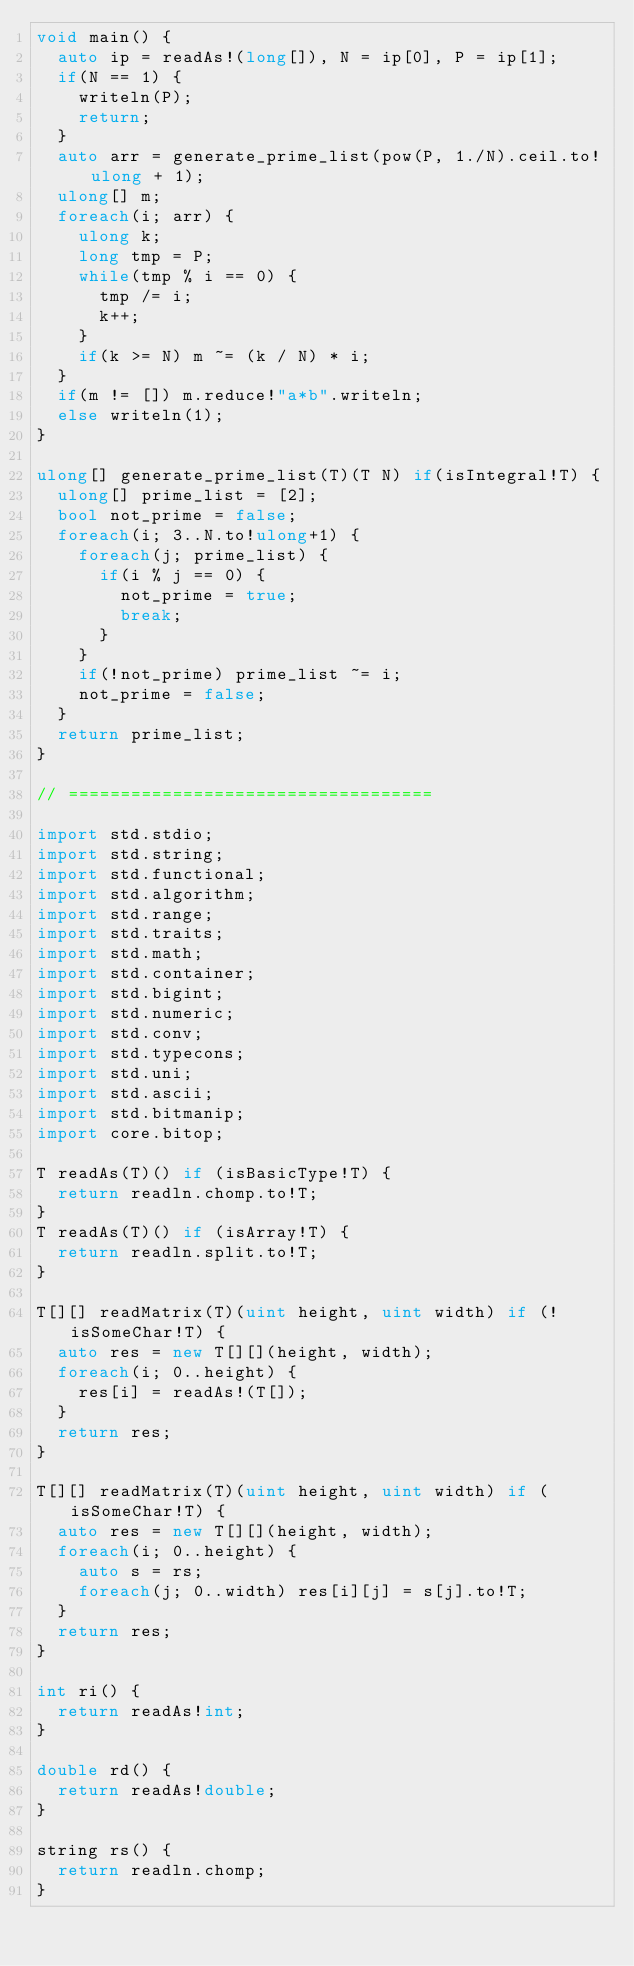<code> <loc_0><loc_0><loc_500><loc_500><_D_>void main() {
	auto ip = readAs!(long[]), N = ip[0], P = ip[1];
	if(N == 1) {
		writeln(P);
		return;
	}
	auto arr = generate_prime_list(pow(P, 1./N).ceil.to!ulong + 1);
	ulong[] m;
	foreach(i; arr) {
		ulong k;
		long tmp = P;
		while(tmp % i == 0) {
			tmp /= i;
			k++;
		}
		if(k >= N) m ~= (k / N) * i;
	}
	if(m != []) m.reduce!"a*b".writeln;
	else writeln(1);
}

ulong[] generate_prime_list(T)(T N) if(isIntegral!T) {
	ulong[] prime_list = [2];
	bool not_prime = false;
	foreach(i; 3..N.to!ulong+1) {
		foreach(j; prime_list) {
			if(i % j == 0) {
				not_prime = true;
				break;
			}
		}
		if(!not_prime) prime_list ~= i;
		not_prime = false;
	}
	return prime_list;
}

// ===================================

import std.stdio;
import std.string;
import std.functional;
import std.algorithm;
import std.range;
import std.traits;
import std.math;
import std.container;
import std.bigint;
import std.numeric;
import std.conv;
import std.typecons;
import std.uni;
import std.ascii;
import std.bitmanip;
import core.bitop;

T readAs(T)() if (isBasicType!T) {
	return readln.chomp.to!T;
}
T readAs(T)() if (isArray!T) {
	return readln.split.to!T;
}

T[][] readMatrix(T)(uint height, uint width) if (!isSomeChar!T) {
	auto res = new T[][](height, width);
	foreach(i; 0..height) {
		res[i] = readAs!(T[]);
	}
	return res;
}

T[][] readMatrix(T)(uint height, uint width) if (isSomeChar!T) {
	auto res = new T[][](height, width);
	foreach(i; 0..height) {
		auto s = rs;
		foreach(j; 0..width) res[i][j] = s[j].to!T;
	}
	return res;
}

int ri() {
	return readAs!int;
}

double rd() {
	return readAs!double;
}

string rs() {
	return readln.chomp;
}
</code> 